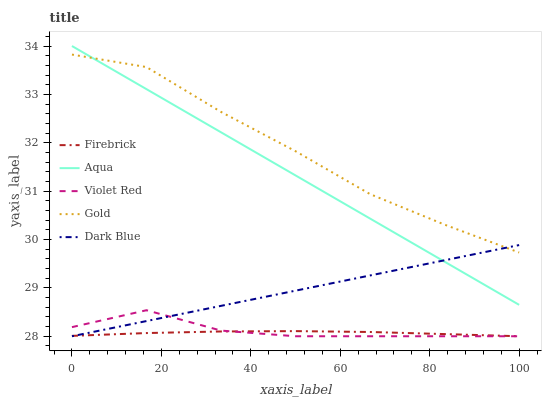Does Firebrick have the minimum area under the curve?
Answer yes or no. Yes. Does Gold have the maximum area under the curve?
Answer yes or no. Yes. Does Aqua have the minimum area under the curve?
Answer yes or no. No. Does Aqua have the maximum area under the curve?
Answer yes or no. No. Is Aqua the smoothest?
Answer yes or no. Yes. Is Violet Red the roughest?
Answer yes or no. Yes. Is Firebrick the smoothest?
Answer yes or no. No. Is Firebrick the roughest?
Answer yes or no. No. Does Aqua have the lowest value?
Answer yes or no. No. Does Aqua have the highest value?
Answer yes or no. Yes. Does Firebrick have the highest value?
Answer yes or no. No. Is Violet Red less than Aqua?
Answer yes or no. Yes. Is Gold greater than Violet Red?
Answer yes or no. Yes. Does Violet Red intersect Firebrick?
Answer yes or no. Yes. Is Violet Red less than Firebrick?
Answer yes or no. No. Is Violet Red greater than Firebrick?
Answer yes or no. No. Does Violet Red intersect Aqua?
Answer yes or no. No. 